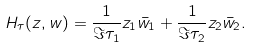Convert formula to latex. <formula><loc_0><loc_0><loc_500><loc_500>H _ { \tau } ( z , w ) = \frac { 1 } { \Im \tau _ { 1 } } z _ { 1 } \bar { w } _ { 1 } + \frac { 1 } { \Im \tau _ { 2 } } z _ { 2 } \bar { w } _ { 2 } .</formula> 